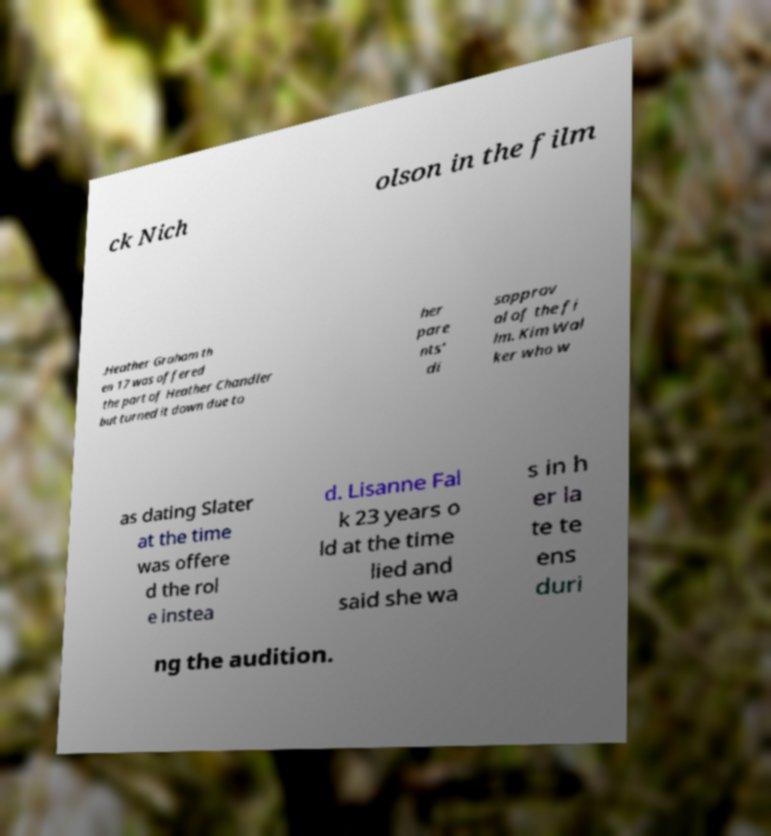Can you accurately transcribe the text from the provided image for me? ck Nich olson in the film .Heather Graham th en 17 was offered the part of Heather Chandler but turned it down due to her pare nts' di sapprov al of the fi lm. Kim Wal ker who w as dating Slater at the time was offere d the rol e instea d. Lisanne Fal k 23 years o ld at the time lied and said she wa s in h er la te te ens duri ng the audition. 